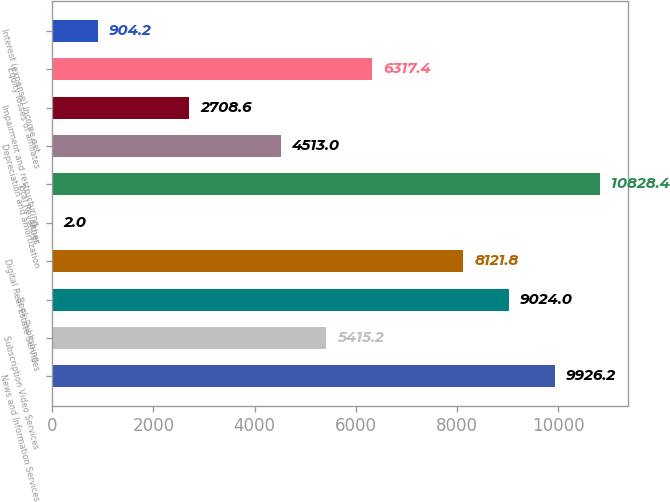Convert chart to OTSL. <chart><loc_0><loc_0><loc_500><loc_500><bar_chart><fcel>News and Information Services<fcel>Subscription Video Services<fcel>Book Publishing<fcel>Digital Real Estate Services<fcel>Other<fcel>Total Revenues<fcel>Depreciation and amortization<fcel>Impairment and restructuring<fcel>Equity losses of affiliates<fcel>Interest (expense) income net<nl><fcel>9926.2<fcel>5415.2<fcel>9024<fcel>8121.8<fcel>2<fcel>10828.4<fcel>4513<fcel>2708.6<fcel>6317.4<fcel>904.2<nl></chart> 